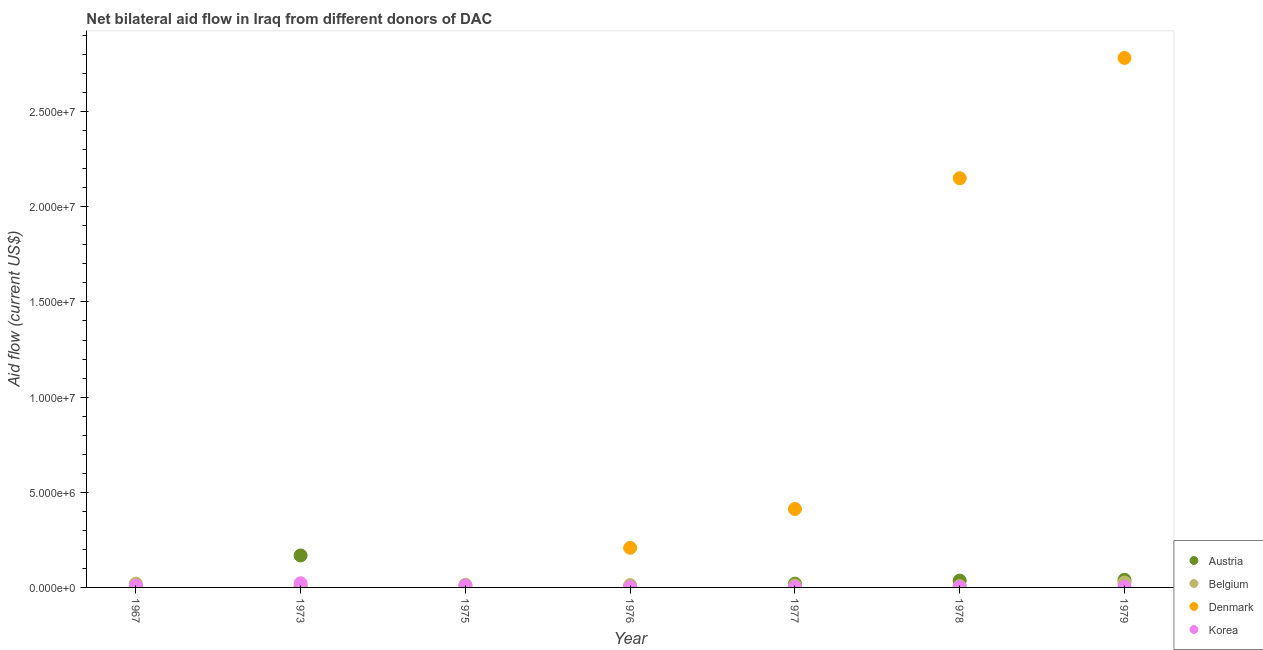Is the number of dotlines equal to the number of legend labels?
Keep it short and to the point. No. What is the amount of aid given by korea in 1975?
Keep it short and to the point. 1.00e+05. Across all years, what is the maximum amount of aid given by korea?
Provide a short and direct response. 2.20e+05. Across all years, what is the minimum amount of aid given by belgium?
Offer a very short reply. 7.00e+04. In which year was the amount of aid given by belgium maximum?
Your answer should be compact. 1979. What is the total amount of aid given by belgium in the graph?
Provide a succinct answer. 9.90e+05. What is the difference between the amount of aid given by austria in 1977 and that in 1979?
Provide a succinct answer. -2.00e+05. What is the difference between the amount of aid given by denmark in 1979 and the amount of aid given by austria in 1976?
Make the answer very short. 2.78e+07. What is the average amount of aid given by korea per year?
Ensure brevity in your answer.  7.14e+04. In the year 1976, what is the difference between the amount of aid given by korea and amount of aid given by austria?
Give a very brief answer. -10000. What is the ratio of the amount of aid given by denmark in 1967 to that in 1976?
Your answer should be compact. 0.01. Is the amount of aid given by belgium in 1975 less than that in 1978?
Make the answer very short. No. Is the difference between the amount of aid given by belgium in 1975 and 1976 greater than the difference between the amount of aid given by denmark in 1975 and 1976?
Make the answer very short. Yes. What is the difference between the highest and the second highest amount of aid given by denmark?
Keep it short and to the point. 6.32e+06. What is the difference between the highest and the lowest amount of aid given by korea?
Your answer should be compact. 2.00e+05. In how many years, is the amount of aid given by austria greater than the average amount of aid given by austria taken over all years?
Your response must be concise. 2. Is it the case that in every year, the sum of the amount of aid given by austria and amount of aid given by belgium is greater than the amount of aid given by denmark?
Offer a terse response. No. Does the amount of aid given by denmark monotonically increase over the years?
Your answer should be very brief. No. How many years are there in the graph?
Make the answer very short. 7. What is the difference between two consecutive major ticks on the Y-axis?
Offer a terse response. 5.00e+06. Does the graph contain any zero values?
Offer a terse response. Yes. Does the graph contain grids?
Keep it short and to the point. No. What is the title of the graph?
Keep it short and to the point. Net bilateral aid flow in Iraq from different donors of DAC. What is the label or title of the X-axis?
Offer a terse response. Year. What is the Aid flow (current US$) of Austria in 1967?
Make the answer very short. 0. What is the Aid flow (current US$) of Austria in 1973?
Your answer should be compact. 1.68e+06. What is the Aid flow (current US$) in Belgium in 1973?
Provide a succinct answer. 1.00e+05. What is the Aid flow (current US$) of Korea in 1973?
Provide a short and direct response. 2.20e+05. What is the Aid flow (current US$) in Austria in 1976?
Offer a terse response. 3.00e+04. What is the Aid flow (current US$) in Belgium in 1976?
Offer a very short reply. 1.20e+05. What is the Aid flow (current US$) of Denmark in 1976?
Make the answer very short. 2.08e+06. What is the Aid flow (current US$) of Korea in 1976?
Offer a terse response. 2.00e+04. What is the Aid flow (current US$) of Austria in 1977?
Your response must be concise. 2.00e+05. What is the Aid flow (current US$) of Denmark in 1977?
Your response must be concise. 4.12e+06. What is the Aid flow (current US$) in Austria in 1978?
Provide a short and direct response. 3.60e+05. What is the Aid flow (current US$) in Denmark in 1978?
Offer a terse response. 2.15e+07. What is the Aid flow (current US$) in Belgium in 1979?
Your answer should be very brief. 2.60e+05. What is the Aid flow (current US$) in Denmark in 1979?
Your answer should be very brief. 2.78e+07. Across all years, what is the maximum Aid flow (current US$) in Austria?
Provide a short and direct response. 1.68e+06. Across all years, what is the maximum Aid flow (current US$) in Belgium?
Your response must be concise. 2.60e+05. Across all years, what is the maximum Aid flow (current US$) in Denmark?
Offer a very short reply. 2.78e+07. Across all years, what is the minimum Aid flow (current US$) in Austria?
Offer a very short reply. 0. Across all years, what is the minimum Aid flow (current US$) in Denmark?
Keep it short and to the point. 2.00e+04. Across all years, what is the minimum Aid flow (current US$) of Korea?
Ensure brevity in your answer.  2.00e+04. What is the total Aid flow (current US$) of Austria in the graph?
Ensure brevity in your answer.  2.67e+06. What is the total Aid flow (current US$) of Belgium in the graph?
Ensure brevity in your answer.  9.90e+05. What is the total Aid flow (current US$) in Denmark in the graph?
Your response must be concise. 5.56e+07. What is the total Aid flow (current US$) of Korea in the graph?
Offer a very short reply. 5.00e+05. What is the difference between the Aid flow (current US$) of Belgium in 1967 and that in 1973?
Provide a succinct answer. 1.00e+05. What is the difference between the Aid flow (current US$) in Denmark in 1967 and that in 1973?
Offer a terse response. 10000. What is the difference between the Aid flow (current US$) of Korea in 1967 and that in 1973?
Provide a succinct answer. -1.30e+05. What is the difference between the Aid flow (current US$) in Belgium in 1967 and that in 1975?
Your answer should be very brief. 6.00e+04. What is the difference between the Aid flow (current US$) in Denmark in 1967 and that in 1975?
Provide a succinct answer. 0. What is the difference between the Aid flow (current US$) of Belgium in 1967 and that in 1976?
Offer a terse response. 8.00e+04. What is the difference between the Aid flow (current US$) in Denmark in 1967 and that in 1976?
Provide a short and direct response. -2.05e+06. What is the difference between the Aid flow (current US$) of Denmark in 1967 and that in 1977?
Provide a short and direct response. -4.09e+06. What is the difference between the Aid flow (current US$) of Denmark in 1967 and that in 1978?
Provide a succinct answer. -2.15e+07. What is the difference between the Aid flow (current US$) of Korea in 1967 and that in 1978?
Ensure brevity in your answer.  7.00e+04. What is the difference between the Aid flow (current US$) in Denmark in 1967 and that in 1979?
Your response must be concise. -2.78e+07. What is the difference between the Aid flow (current US$) in Korea in 1967 and that in 1979?
Make the answer very short. 6.00e+04. What is the difference between the Aid flow (current US$) of Korea in 1973 and that in 1975?
Provide a succinct answer. 1.20e+05. What is the difference between the Aid flow (current US$) of Austria in 1973 and that in 1976?
Ensure brevity in your answer.  1.65e+06. What is the difference between the Aid flow (current US$) in Belgium in 1973 and that in 1976?
Give a very brief answer. -2.00e+04. What is the difference between the Aid flow (current US$) in Denmark in 1973 and that in 1976?
Your response must be concise. -2.06e+06. What is the difference between the Aid flow (current US$) of Austria in 1973 and that in 1977?
Offer a very short reply. 1.48e+06. What is the difference between the Aid flow (current US$) of Denmark in 1973 and that in 1977?
Keep it short and to the point. -4.10e+06. What is the difference between the Aid flow (current US$) of Austria in 1973 and that in 1978?
Your answer should be compact. 1.32e+06. What is the difference between the Aid flow (current US$) of Belgium in 1973 and that in 1978?
Your answer should be very brief. 3.00e+04. What is the difference between the Aid flow (current US$) in Denmark in 1973 and that in 1978?
Your answer should be very brief. -2.15e+07. What is the difference between the Aid flow (current US$) in Korea in 1973 and that in 1978?
Give a very brief answer. 2.00e+05. What is the difference between the Aid flow (current US$) of Austria in 1973 and that in 1979?
Provide a short and direct response. 1.28e+06. What is the difference between the Aid flow (current US$) in Denmark in 1973 and that in 1979?
Provide a short and direct response. -2.78e+07. What is the difference between the Aid flow (current US$) of Korea in 1973 and that in 1979?
Give a very brief answer. 1.90e+05. What is the difference between the Aid flow (current US$) in Belgium in 1975 and that in 1976?
Your answer should be compact. 2.00e+04. What is the difference between the Aid flow (current US$) in Denmark in 1975 and that in 1976?
Your answer should be very brief. -2.05e+06. What is the difference between the Aid flow (current US$) of Denmark in 1975 and that in 1977?
Your response must be concise. -4.09e+06. What is the difference between the Aid flow (current US$) in Korea in 1975 and that in 1977?
Your answer should be very brief. 8.00e+04. What is the difference between the Aid flow (current US$) in Denmark in 1975 and that in 1978?
Offer a very short reply. -2.15e+07. What is the difference between the Aid flow (current US$) of Denmark in 1975 and that in 1979?
Give a very brief answer. -2.78e+07. What is the difference between the Aid flow (current US$) of Austria in 1976 and that in 1977?
Keep it short and to the point. -1.70e+05. What is the difference between the Aid flow (current US$) in Denmark in 1976 and that in 1977?
Give a very brief answer. -2.04e+06. What is the difference between the Aid flow (current US$) of Austria in 1976 and that in 1978?
Offer a terse response. -3.30e+05. What is the difference between the Aid flow (current US$) of Denmark in 1976 and that in 1978?
Offer a very short reply. -1.94e+07. What is the difference between the Aid flow (current US$) of Korea in 1976 and that in 1978?
Offer a very short reply. 0. What is the difference between the Aid flow (current US$) in Austria in 1976 and that in 1979?
Make the answer very short. -3.70e+05. What is the difference between the Aid flow (current US$) in Belgium in 1976 and that in 1979?
Keep it short and to the point. -1.40e+05. What is the difference between the Aid flow (current US$) in Denmark in 1976 and that in 1979?
Make the answer very short. -2.57e+07. What is the difference between the Aid flow (current US$) of Korea in 1976 and that in 1979?
Make the answer very short. -10000. What is the difference between the Aid flow (current US$) of Austria in 1977 and that in 1978?
Your answer should be very brief. -1.60e+05. What is the difference between the Aid flow (current US$) in Denmark in 1977 and that in 1978?
Provide a short and direct response. -1.74e+07. What is the difference between the Aid flow (current US$) of Denmark in 1977 and that in 1979?
Your answer should be very brief. -2.37e+07. What is the difference between the Aid flow (current US$) in Belgium in 1978 and that in 1979?
Provide a short and direct response. -1.90e+05. What is the difference between the Aid flow (current US$) of Denmark in 1978 and that in 1979?
Provide a short and direct response. -6.32e+06. What is the difference between the Aid flow (current US$) in Korea in 1978 and that in 1979?
Your answer should be compact. -10000. What is the difference between the Aid flow (current US$) in Belgium in 1967 and the Aid flow (current US$) in Denmark in 1975?
Offer a very short reply. 1.70e+05. What is the difference between the Aid flow (current US$) in Belgium in 1967 and the Aid flow (current US$) in Korea in 1975?
Your answer should be compact. 1.00e+05. What is the difference between the Aid flow (current US$) of Denmark in 1967 and the Aid flow (current US$) of Korea in 1975?
Keep it short and to the point. -7.00e+04. What is the difference between the Aid flow (current US$) in Belgium in 1967 and the Aid flow (current US$) in Denmark in 1976?
Make the answer very short. -1.88e+06. What is the difference between the Aid flow (current US$) in Belgium in 1967 and the Aid flow (current US$) in Korea in 1976?
Your response must be concise. 1.80e+05. What is the difference between the Aid flow (current US$) in Belgium in 1967 and the Aid flow (current US$) in Denmark in 1977?
Your answer should be very brief. -3.92e+06. What is the difference between the Aid flow (current US$) of Belgium in 1967 and the Aid flow (current US$) of Korea in 1977?
Offer a very short reply. 1.80e+05. What is the difference between the Aid flow (current US$) of Belgium in 1967 and the Aid flow (current US$) of Denmark in 1978?
Provide a succinct answer. -2.13e+07. What is the difference between the Aid flow (current US$) in Denmark in 1967 and the Aid flow (current US$) in Korea in 1978?
Make the answer very short. 10000. What is the difference between the Aid flow (current US$) of Belgium in 1967 and the Aid flow (current US$) of Denmark in 1979?
Your answer should be very brief. -2.76e+07. What is the difference between the Aid flow (current US$) in Denmark in 1967 and the Aid flow (current US$) in Korea in 1979?
Your answer should be very brief. 0. What is the difference between the Aid flow (current US$) in Austria in 1973 and the Aid flow (current US$) in Belgium in 1975?
Ensure brevity in your answer.  1.54e+06. What is the difference between the Aid flow (current US$) of Austria in 1973 and the Aid flow (current US$) of Denmark in 1975?
Give a very brief answer. 1.65e+06. What is the difference between the Aid flow (current US$) of Austria in 1973 and the Aid flow (current US$) of Korea in 1975?
Offer a terse response. 1.58e+06. What is the difference between the Aid flow (current US$) of Belgium in 1973 and the Aid flow (current US$) of Denmark in 1975?
Offer a very short reply. 7.00e+04. What is the difference between the Aid flow (current US$) of Belgium in 1973 and the Aid flow (current US$) of Korea in 1975?
Keep it short and to the point. 0. What is the difference between the Aid flow (current US$) of Denmark in 1973 and the Aid flow (current US$) of Korea in 1975?
Your answer should be very brief. -8.00e+04. What is the difference between the Aid flow (current US$) in Austria in 1973 and the Aid flow (current US$) in Belgium in 1976?
Provide a short and direct response. 1.56e+06. What is the difference between the Aid flow (current US$) in Austria in 1973 and the Aid flow (current US$) in Denmark in 1976?
Offer a very short reply. -4.00e+05. What is the difference between the Aid flow (current US$) in Austria in 1973 and the Aid flow (current US$) in Korea in 1976?
Your answer should be compact. 1.66e+06. What is the difference between the Aid flow (current US$) of Belgium in 1973 and the Aid flow (current US$) of Denmark in 1976?
Provide a short and direct response. -1.98e+06. What is the difference between the Aid flow (current US$) in Austria in 1973 and the Aid flow (current US$) in Belgium in 1977?
Offer a very short reply. 1.58e+06. What is the difference between the Aid flow (current US$) in Austria in 1973 and the Aid flow (current US$) in Denmark in 1977?
Your answer should be very brief. -2.44e+06. What is the difference between the Aid flow (current US$) of Austria in 1973 and the Aid flow (current US$) of Korea in 1977?
Give a very brief answer. 1.66e+06. What is the difference between the Aid flow (current US$) in Belgium in 1973 and the Aid flow (current US$) in Denmark in 1977?
Your response must be concise. -4.02e+06. What is the difference between the Aid flow (current US$) of Austria in 1973 and the Aid flow (current US$) of Belgium in 1978?
Provide a succinct answer. 1.61e+06. What is the difference between the Aid flow (current US$) in Austria in 1973 and the Aid flow (current US$) in Denmark in 1978?
Your answer should be compact. -1.98e+07. What is the difference between the Aid flow (current US$) in Austria in 1973 and the Aid flow (current US$) in Korea in 1978?
Make the answer very short. 1.66e+06. What is the difference between the Aid flow (current US$) of Belgium in 1973 and the Aid flow (current US$) of Denmark in 1978?
Provide a short and direct response. -2.14e+07. What is the difference between the Aid flow (current US$) in Belgium in 1973 and the Aid flow (current US$) in Korea in 1978?
Provide a short and direct response. 8.00e+04. What is the difference between the Aid flow (current US$) of Denmark in 1973 and the Aid flow (current US$) of Korea in 1978?
Ensure brevity in your answer.  0. What is the difference between the Aid flow (current US$) in Austria in 1973 and the Aid flow (current US$) in Belgium in 1979?
Provide a short and direct response. 1.42e+06. What is the difference between the Aid flow (current US$) in Austria in 1973 and the Aid flow (current US$) in Denmark in 1979?
Offer a very short reply. -2.61e+07. What is the difference between the Aid flow (current US$) of Austria in 1973 and the Aid flow (current US$) of Korea in 1979?
Ensure brevity in your answer.  1.65e+06. What is the difference between the Aid flow (current US$) in Belgium in 1973 and the Aid flow (current US$) in Denmark in 1979?
Offer a very short reply. -2.77e+07. What is the difference between the Aid flow (current US$) of Belgium in 1975 and the Aid flow (current US$) of Denmark in 1976?
Give a very brief answer. -1.94e+06. What is the difference between the Aid flow (current US$) of Belgium in 1975 and the Aid flow (current US$) of Denmark in 1977?
Your answer should be compact. -3.98e+06. What is the difference between the Aid flow (current US$) of Belgium in 1975 and the Aid flow (current US$) of Denmark in 1978?
Make the answer very short. -2.14e+07. What is the difference between the Aid flow (current US$) of Belgium in 1975 and the Aid flow (current US$) of Denmark in 1979?
Keep it short and to the point. -2.77e+07. What is the difference between the Aid flow (current US$) of Denmark in 1975 and the Aid flow (current US$) of Korea in 1979?
Make the answer very short. 0. What is the difference between the Aid flow (current US$) of Austria in 1976 and the Aid flow (current US$) of Denmark in 1977?
Your answer should be very brief. -4.09e+06. What is the difference between the Aid flow (current US$) of Belgium in 1976 and the Aid flow (current US$) of Korea in 1977?
Your answer should be compact. 1.00e+05. What is the difference between the Aid flow (current US$) in Denmark in 1976 and the Aid flow (current US$) in Korea in 1977?
Provide a succinct answer. 2.06e+06. What is the difference between the Aid flow (current US$) of Austria in 1976 and the Aid flow (current US$) of Belgium in 1978?
Make the answer very short. -4.00e+04. What is the difference between the Aid flow (current US$) of Austria in 1976 and the Aid flow (current US$) of Denmark in 1978?
Provide a succinct answer. -2.15e+07. What is the difference between the Aid flow (current US$) of Belgium in 1976 and the Aid flow (current US$) of Denmark in 1978?
Your answer should be very brief. -2.14e+07. What is the difference between the Aid flow (current US$) in Belgium in 1976 and the Aid flow (current US$) in Korea in 1978?
Give a very brief answer. 1.00e+05. What is the difference between the Aid flow (current US$) of Denmark in 1976 and the Aid flow (current US$) of Korea in 1978?
Offer a terse response. 2.06e+06. What is the difference between the Aid flow (current US$) of Austria in 1976 and the Aid flow (current US$) of Belgium in 1979?
Your response must be concise. -2.30e+05. What is the difference between the Aid flow (current US$) in Austria in 1976 and the Aid flow (current US$) in Denmark in 1979?
Give a very brief answer. -2.78e+07. What is the difference between the Aid flow (current US$) in Austria in 1976 and the Aid flow (current US$) in Korea in 1979?
Your answer should be compact. 0. What is the difference between the Aid flow (current US$) in Belgium in 1976 and the Aid flow (current US$) in Denmark in 1979?
Ensure brevity in your answer.  -2.77e+07. What is the difference between the Aid flow (current US$) of Denmark in 1976 and the Aid flow (current US$) of Korea in 1979?
Your answer should be compact. 2.05e+06. What is the difference between the Aid flow (current US$) of Austria in 1977 and the Aid flow (current US$) of Denmark in 1978?
Provide a short and direct response. -2.13e+07. What is the difference between the Aid flow (current US$) of Austria in 1977 and the Aid flow (current US$) of Korea in 1978?
Your answer should be very brief. 1.80e+05. What is the difference between the Aid flow (current US$) of Belgium in 1977 and the Aid flow (current US$) of Denmark in 1978?
Offer a very short reply. -2.14e+07. What is the difference between the Aid flow (current US$) of Belgium in 1977 and the Aid flow (current US$) of Korea in 1978?
Offer a terse response. 8.00e+04. What is the difference between the Aid flow (current US$) in Denmark in 1977 and the Aid flow (current US$) in Korea in 1978?
Your answer should be compact. 4.10e+06. What is the difference between the Aid flow (current US$) in Austria in 1977 and the Aid flow (current US$) in Belgium in 1979?
Your answer should be very brief. -6.00e+04. What is the difference between the Aid flow (current US$) in Austria in 1977 and the Aid flow (current US$) in Denmark in 1979?
Offer a terse response. -2.76e+07. What is the difference between the Aid flow (current US$) in Belgium in 1977 and the Aid flow (current US$) in Denmark in 1979?
Your answer should be very brief. -2.77e+07. What is the difference between the Aid flow (current US$) in Belgium in 1977 and the Aid flow (current US$) in Korea in 1979?
Provide a short and direct response. 7.00e+04. What is the difference between the Aid flow (current US$) in Denmark in 1977 and the Aid flow (current US$) in Korea in 1979?
Provide a short and direct response. 4.09e+06. What is the difference between the Aid flow (current US$) in Austria in 1978 and the Aid flow (current US$) in Denmark in 1979?
Keep it short and to the point. -2.75e+07. What is the difference between the Aid flow (current US$) in Austria in 1978 and the Aid flow (current US$) in Korea in 1979?
Provide a succinct answer. 3.30e+05. What is the difference between the Aid flow (current US$) of Belgium in 1978 and the Aid flow (current US$) of Denmark in 1979?
Keep it short and to the point. -2.78e+07. What is the difference between the Aid flow (current US$) of Denmark in 1978 and the Aid flow (current US$) of Korea in 1979?
Provide a short and direct response. 2.15e+07. What is the average Aid flow (current US$) of Austria per year?
Your response must be concise. 3.81e+05. What is the average Aid flow (current US$) of Belgium per year?
Ensure brevity in your answer.  1.41e+05. What is the average Aid flow (current US$) in Denmark per year?
Your answer should be compact. 7.94e+06. What is the average Aid flow (current US$) of Korea per year?
Keep it short and to the point. 7.14e+04. In the year 1967, what is the difference between the Aid flow (current US$) of Belgium and Aid flow (current US$) of Denmark?
Make the answer very short. 1.70e+05. In the year 1967, what is the difference between the Aid flow (current US$) in Belgium and Aid flow (current US$) in Korea?
Your answer should be very brief. 1.10e+05. In the year 1967, what is the difference between the Aid flow (current US$) in Denmark and Aid flow (current US$) in Korea?
Offer a very short reply. -6.00e+04. In the year 1973, what is the difference between the Aid flow (current US$) in Austria and Aid flow (current US$) in Belgium?
Your response must be concise. 1.58e+06. In the year 1973, what is the difference between the Aid flow (current US$) in Austria and Aid flow (current US$) in Denmark?
Your response must be concise. 1.66e+06. In the year 1973, what is the difference between the Aid flow (current US$) in Austria and Aid flow (current US$) in Korea?
Give a very brief answer. 1.46e+06. In the year 1973, what is the difference between the Aid flow (current US$) of Belgium and Aid flow (current US$) of Korea?
Ensure brevity in your answer.  -1.20e+05. In the year 1975, what is the difference between the Aid flow (current US$) in Belgium and Aid flow (current US$) in Korea?
Offer a very short reply. 4.00e+04. In the year 1976, what is the difference between the Aid flow (current US$) in Austria and Aid flow (current US$) in Belgium?
Your answer should be compact. -9.00e+04. In the year 1976, what is the difference between the Aid flow (current US$) of Austria and Aid flow (current US$) of Denmark?
Ensure brevity in your answer.  -2.05e+06. In the year 1976, what is the difference between the Aid flow (current US$) in Belgium and Aid flow (current US$) in Denmark?
Offer a terse response. -1.96e+06. In the year 1976, what is the difference between the Aid flow (current US$) of Denmark and Aid flow (current US$) of Korea?
Offer a very short reply. 2.06e+06. In the year 1977, what is the difference between the Aid flow (current US$) in Austria and Aid flow (current US$) in Denmark?
Provide a succinct answer. -3.92e+06. In the year 1977, what is the difference between the Aid flow (current US$) in Austria and Aid flow (current US$) in Korea?
Offer a terse response. 1.80e+05. In the year 1977, what is the difference between the Aid flow (current US$) of Belgium and Aid flow (current US$) of Denmark?
Give a very brief answer. -4.02e+06. In the year 1977, what is the difference between the Aid flow (current US$) of Belgium and Aid flow (current US$) of Korea?
Your answer should be very brief. 8.00e+04. In the year 1977, what is the difference between the Aid flow (current US$) in Denmark and Aid flow (current US$) in Korea?
Ensure brevity in your answer.  4.10e+06. In the year 1978, what is the difference between the Aid flow (current US$) of Austria and Aid flow (current US$) of Belgium?
Offer a very short reply. 2.90e+05. In the year 1978, what is the difference between the Aid flow (current US$) in Austria and Aid flow (current US$) in Denmark?
Your response must be concise. -2.11e+07. In the year 1978, what is the difference between the Aid flow (current US$) in Austria and Aid flow (current US$) in Korea?
Your answer should be very brief. 3.40e+05. In the year 1978, what is the difference between the Aid flow (current US$) in Belgium and Aid flow (current US$) in Denmark?
Your answer should be compact. -2.14e+07. In the year 1978, what is the difference between the Aid flow (current US$) of Denmark and Aid flow (current US$) of Korea?
Provide a short and direct response. 2.15e+07. In the year 1979, what is the difference between the Aid flow (current US$) in Austria and Aid flow (current US$) in Belgium?
Ensure brevity in your answer.  1.40e+05. In the year 1979, what is the difference between the Aid flow (current US$) of Austria and Aid flow (current US$) of Denmark?
Offer a terse response. -2.74e+07. In the year 1979, what is the difference between the Aid flow (current US$) in Belgium and Aid flow (current US$) in Denmark?
Your answer should be very brief. -2.76e+07. In the year 1979, what is the difference between the Aid flow (current US$) of Belgium and Aid flow (current US$) of Korea?
Ensure brevity in your answer.  2.30e+05. In the year 1979, what is the difference between the Aid flow (current US$) in Denmark and Aid flow (current US$) in Korea?
Keep it short and to the point. 2.78e+07. What is the ratio of the Aid flow (current US$) in Belgium in 1967 to that in 1973?
Ensure brevity in your answer.  2. What is the ratio of the Aid flow (current US$) of Korea in 1967 to that in 1973?
Your response must be concise. 0.41. What is the ratio of the Aid flow (current US$) of Belgium in 1967 to that in 1975?
Your answer should be compact. 1.43. What is the ratio of the Aid flow (current US$) in Denmark in 1967 to that in 1975?
Ensure brevity in your answer.  1. What is the ratio of the Aid flow (current US$) of Belgium in 1967 to that in 1976?
Provide a short and direct response. 1.67. What is the ratio of the Aid flow (current US$) of Denmark in 1967 to that in 1976?
Give a very brief answer. 0.01. What is the ratio of the Aid flow (current US$) of Belgium in 1967 to that in 1977?
Offer a terse response. 2. What is the ratio of the Aid flow (current US$) of Denmark in 1967 to that in 1977?
Offer a terse response. 0.01. What is the ratio of the Aid flow (current US$) of Korea in 1967 to that in 1977?
Make the answer very short. 4.5. What is the ratio of the Aid flow (current US$) in Belgium in 1967 to that in 1978?
Offer a very short reply. 2.86. What is the ratio of the Aid flow (current US$) in Denmark in 1967 to that in 1978?
Offer a terse response. 0. What is the ratio of the Aid flow (current US$) of Belgium in 1967 to that in 1979?
Your answer should be very brief. 0.77. What is the ratio of the Aid flow (current US$) in Denmark in 1967 to that in 1979?
Keep it short and to the point. 0. What is the ratio of the Aid flow (current US$) in Belgium in 1973 to that in 1975?
Give a very brief answer. 0.71. What is the ratio of the Aid flow (current US$) of Denmark in 1973 to that in 1975?
Your answer should be very brief. 0.67. What is the ratio of the Aid flow (current US$) in Denmark in 1973 to that in 1976?
Give a very brief answer. 0.01. What is the ratio of the Aid flow (current US$) of Korea in 1973 to that in 1976?
Offer a very short reply. 11. What is the ratio of the Aid flow (current US$) in Austria in 1973 to that in 1977?
Your answer should be compact. 8.4. What is the ratio of the Aid flow (current US$) of Belgium in 1973 to that in 1977?
Ensure brevity in your answer.  1. What is the ratio of the Aid flow (current US$) of Denmark in 1973 to that in 1977?
Your answer should be compact. 0. What is the ratio of the Aid flow (current US$) of Korea in 1973 to that in 1977?
Offer a very short reply. 11. What is the ratio of the Aid flow (current US$) in Austria in 1973 to that in 1978?
Give a very brief answer. 4.67. What is the ratio of the Aid flow (current US$) in Belgium in 1973 to that in 1978?
Offer a very short reply. 1.43. What is the ratio of the Aid flow (current US$) of Denmark in 1973 to that in 1978?
Offer a terse response. 0. What is the ratio of the Aid flow (current US$) in Austria in 1973 to that in 1979?
Give a very brief answer. 4.2. What is the ratio of the Aid flow (current US$) of Belgium in 1973 to that in 1979?
Provide a succinct answer. 0.38. What is the ratio of the Aid flow (current US$) of Denmark in 1973 to that in 1979?
Offer a very short reply. 0. What is the ratio of the Aid flow (current US$) of Korea in 1973 to that in 1979?
Give a very brief answer. 7.33. What is the ratio of the Aid flow (current US$) of Denmark in 1975 to that in 1976?
Keep it short and to the point. 0.01. What is the ratio of the Aid flow (current US$) of Korea in 1975 to that in 1976?
Your answer should be compact. 5. What is the ratio of the Aid flow (current US$) in Denmark in 1975 to that in 1977?
Your answer should be very brief. 0.01. What is the ratio of the Aid flow (current US$) in Denmark in 1975 to that in 1978?
Your response must be concise. 0. What is the ratio of the Aid flow (current US$) of Belgium in 1975 to that in 1979?
Make the answer very short. 0.54. What is the ratio of the Aid flow (current US$) of Denmark in 1975 to that in 1979?
Give a very brief answer. 0. What is the ratio of the Aid flow (current US$) in Korea in 1975 to that in 1979?
Give a very brief answer. 3.33. What is the ratio of the Aid flow (current US$) in Belgium in 1976 to that in 1977?
Your answer should be very brief. 1.2. What is the ratio of the Aid flow (current US$) in Denmark in 1976 to that in 1977?
Your response must be concise. 0.5. What is the ratio of the Aid flow (current US$) of Korea in 1976 to that in 1977?
Offer a terse response. 1. What is the ratio of the Aid flow (current US$) of Austria in 1976 to that in 1978?
Provide a succinct answer. 0.08. What is the ratio of the Aid flow (current US$) of Belgium in 1976 to that in 1978?
Your response must be concise. 1.71. What is the ratio of the Aid flow (current US$) in Denmark in 1976 to that in 1978?
Keep it short and to the point. 0.1. What is the ratio of the Aid flow (current US$) of Austria in 1976 to that in 1979?
Provide a short and direct response. 0.07. What is the ratio of the Aid flow (current US$) in Belgium in 1976 to that in 1979?
Your response must be concise. 0.46. What is the ratio of the Aid flow (current US$) in Denmark in 1976 to that in 1979?
Your response must be concise. 0.07. What is the ratio of the Aid flow (current US$) of Korea in 1976 to that in 1979?
Give a very brief answer. 0.67. What is the ratio of the Aid flow (current US$) in Austria in 1977 to that in 1978?
Ensure brevity in your answer.  0.56. What is the ratio of the Aid flow (current US$) in Belgium in 1977 to that in 1978?
Provide a succinct answer. 1.43. What is the ratio of the Aid flow (current US$) of Denmark in 1977 to that in 1978?
Provide a short and direct response. 0.19. What is the ratio of the Aid flow (current US$) in Austria in 1977 to that in 1979?
Make the answer very short. 0.5. What is the ratio of the Aid flow (current US$) of Belgium in 1977 to that in 1979?
Keep it short and to the point. 0.38. What is the ratio of the Aid flow (current US$) of Denmark in 1977 to that in 1979?
Provide a succinct answer. 0.15. What is the ratio of the Aid flow (current US$) of Austria in 1978 to that in 1979?
Your answer should be very brief. 0.9. What is the ratio of the Aid flow (current US$) of Belgium in 1978 to that in 1979?
Offer a terse response. 0.27. What is the ratio of the Aid flow (current US$) in Denmark in 1978 to that in 1979?
Your answer should be very brief. 0.77. What is the difference between the highest and the second highest Aid flow (current US$) in Austria?
Ensure brevity in your answer.  1.28e+06. What is the difference between the highest and the second highest Aid flow (current US$) of Belgium?
Offer a very short reply. 6.00e+04. What is the difference between the highest and the second highest Aid flow (current US$) in Denmark?
Your answer should be very brief. 6.32e+06. What is the difference between the highest and the lowest Aid flow (current US$) in Austria?
Your answer should be compact. 1.68e+06. What is the difference between the highest and the lowest Aid flow (current US$) of Belgium?
Provide a short and direct response. 1.90e+05. What is the difference between the highest and the lowest Aid flow (current US$) in Denmark?
Provide a short and direct response. 2.78e+07. What is the difference between the highest and the lowest Aid flow (current US$) of Korea?
Your answer should be compact. 2.00e+05. 